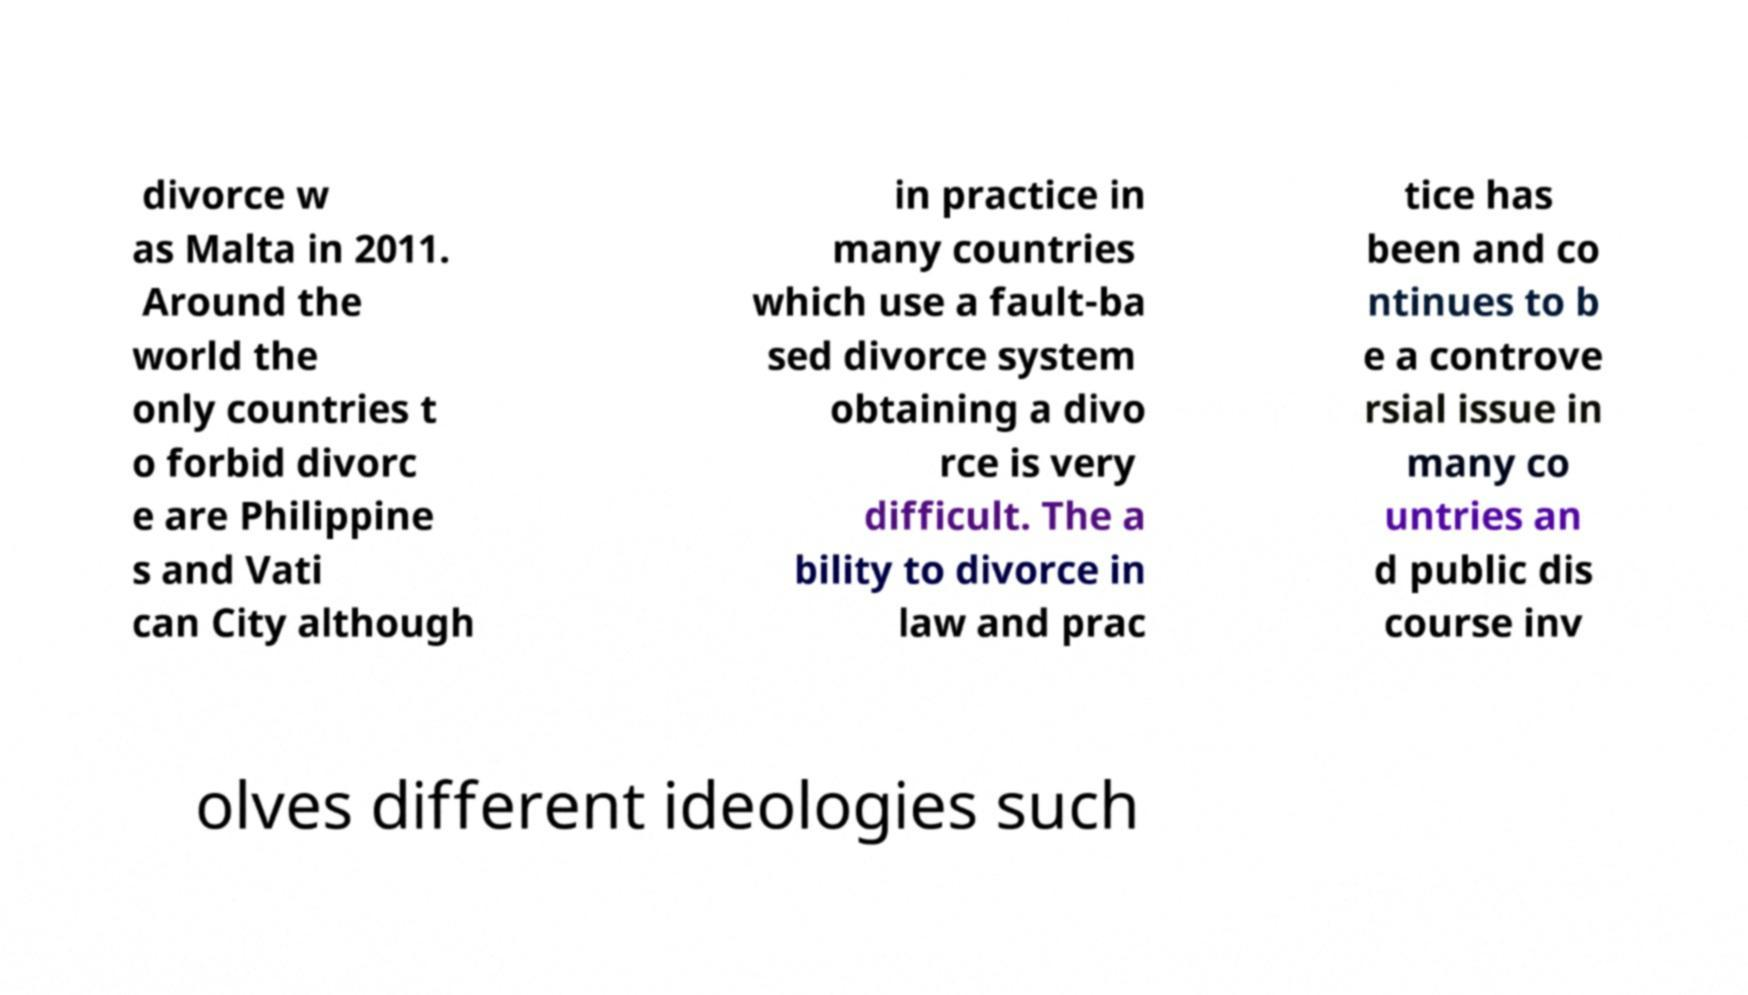I need the written content from this picture converted into text. Can you do that? divorce w as Malta in 2011. Around the world the only countries t o forbid divorc e are Philippine s and Vati can City although in practice in many countries which use a fault-ba sed divorce system obtaining a divo rce is very difficult. The a bility to divorce in law and prac tice has been and co ntinues to b e a controve rsial issue in many co untries an d public dis course inv olves different ideologies such 